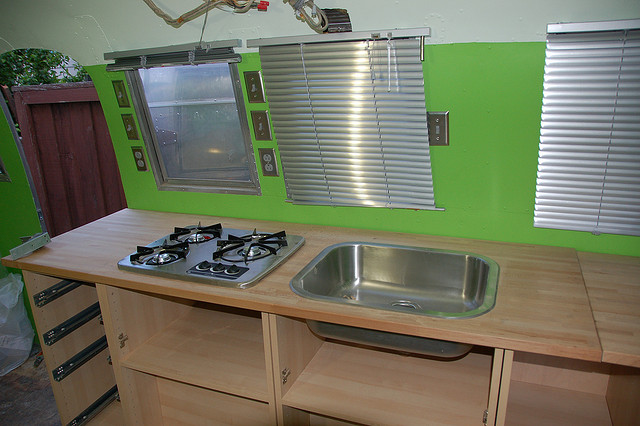<image>What is required in order to be able to use this equipment? It is unknown what is required to use this equipment. However, it might require 'plumbing and wiring', 'cooking skills', 'hands', 'fire', 'faucet', 'water', 'electricity', or a 'stove'. What is required in order to be able to use this equipment? It is unknown what is required in order to be able to use this equipment. It can be plumbing and wiring, cooking skills, or hands. 